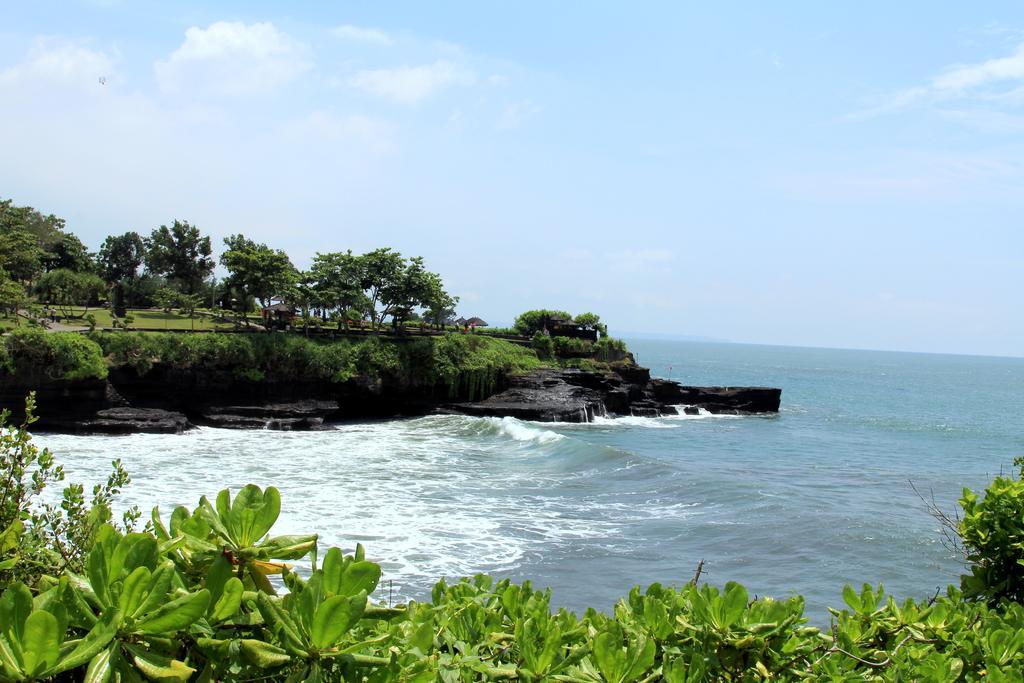Please provide a concise description of this image. At the bottom of the picture, we see plants or trees. In the middle of the picture, we see water and this water might be in the river. There are trees in the background. At the top of the picture, we see the sky, which is blue in color. 